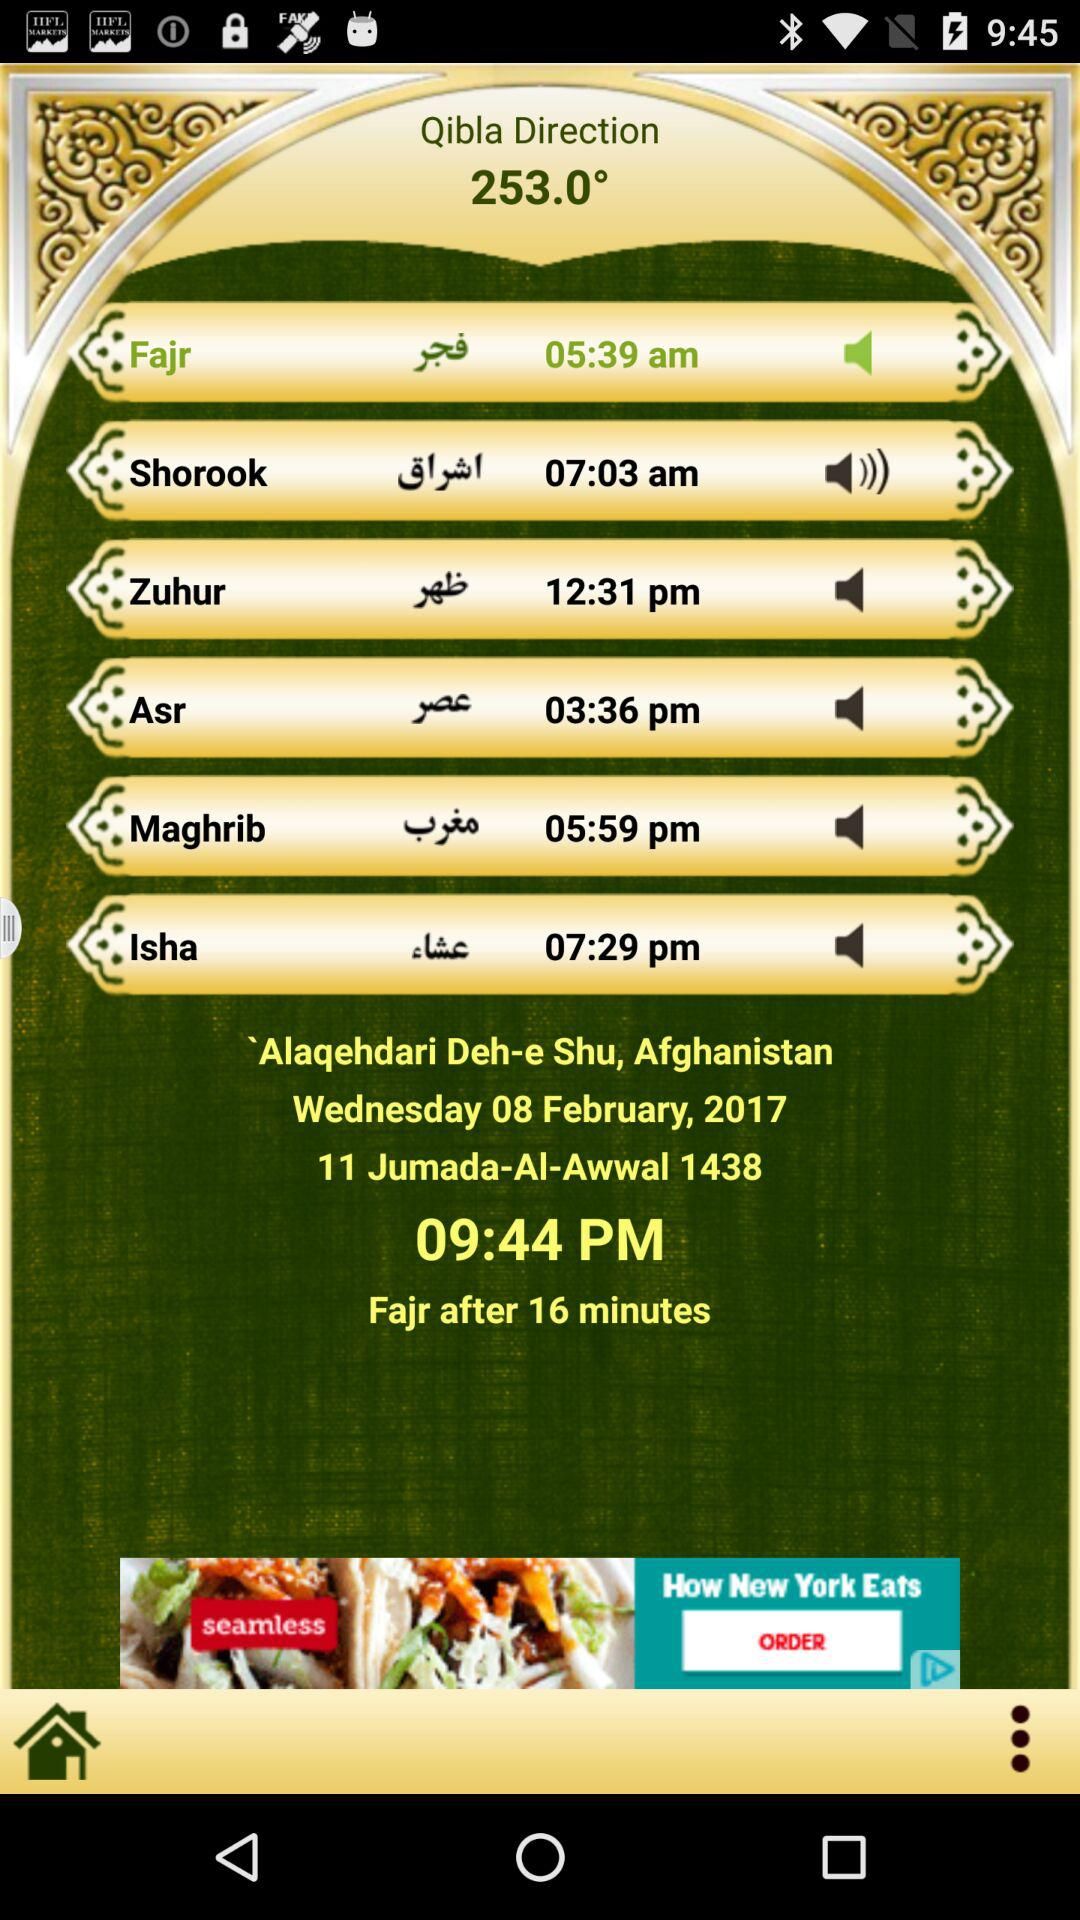At what time did Isha start? Isha started at 07:29 pm. 